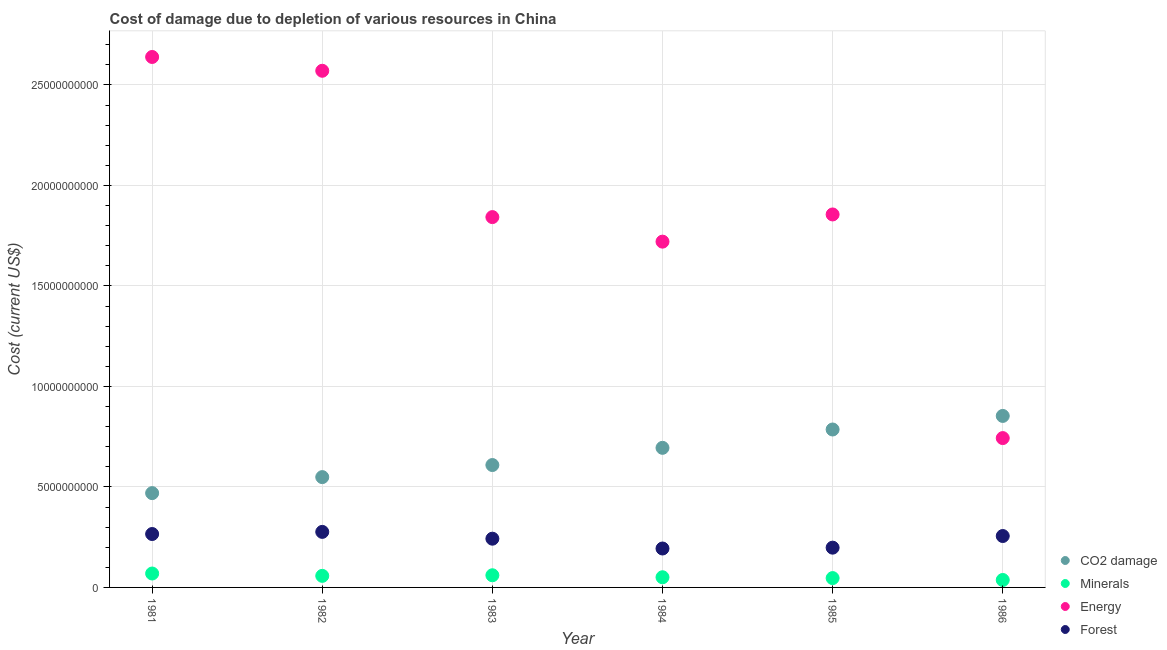How many different coloured dotlines are there?
Provide a succinct answer. 4. Is the number of dotlines equal to the number of legend labels?
Your response must be concise. Yes. What is the cost of damage due to depletion of minerals in 1981?
Make the answer very short. 6.92e+08. Across all years, what is the maximum cost of damage due to depletion of coal?
Your answer should be very brief. 8.53e+09. Across all years, what is the minimum cost of damage due to depletion of energy?
Your answer should be very brief. 7.43e+09. In which year was the cost of damage due to depletion of coal maximum?
Give a very brief answer. 1986. In which year was the cost of damage due to depletion of forests minimum?
Offer a terse response. 1984. What is the total cost of damage due to depletion of forests in the graph?
Your answer should be compact. 1.43e+1. What is the difference between the cost of damage due to depletion of minerals in 1982 and that in 1984?
Keep it short and to the point. 6.97e+07. What is the difference between the cost of damage due to depletion of minerals in 1983 and the cost of damage due to depletion of coal in 1986?
Offer a very short reply. -7.93e+09. What is the average cost of damage due to depletion of minerals per year?
Offer a terse response. 5.36e+08. In the year 1984, what is the difference between the cost of damage due to depletion of coal and cost of damage due to depletion of energy?
Provide a short and direct response. -1.03e+1. In how many years, is the cost of damage due to depletion of coal greater than 25000000000 US$?
Keep it short and to the point. 0. What is the ratio of the cost of damage due to depletion of minerals in 1984 to that in 1986?
Offer a terse response. 1.36. Is the difference between the cost of damage due to depletion of coal in 1981 and 1982 greater than the difference between the cost of damage due to depletion of minerals in 1981 and 1982?
Make the answer very short. No. What is the difference between the highest and the second highest cost of damage due to depletion of energy?
Offer a terse response. 6.87e+08. What is the difference between the highest and the lowest cost of damage due to depletion of minerals?
Keep it short and to the point. 3.21e+08. Is it the case that in every year, the sum of the cost of damage due to depletion of coal and cost of damage due to depletion of minerals is greater than the cost of damage due to depletion of energy?
Provide a short and direct response. No. Is the cost of damage due to depletion of energy strictly greater than the cost of damage due to depletion of minerals over the years?
Provide a short and direct response. Yes. How many years are there in the graph?
Offer a very short reply. 6. Does the graph contain any zero values?
Provide a succinct answer. No. Does the graph contain grids?
Provide a succinct answer. Yes. How many legend labels are there?
Give a very brief answer. 4. How are the legend labels stacked?
Make the answer very short. Vertical. What is the title of the graph?
Give a very brief answer. Cost of damage due to depletion of various resources in China . What is the label or title of the Y-axis?
Give a very brief answer. Cost (current US$). What is the Cost (current US$) in CO2 damage in 1981?
Your answer should be very brief. 4.69e+09. What is the Cost (current US$) in Minerals in 1981?
Your response must be concise. 6.92e+08. What is the Cost (current US$) in Energy in 1981?
Make the answer very short. 2.64e+1. What is the Cost (current US$) in Forest in 1981?
Give a very brief answer. 2.66e+09. What is the Cost (current US$) of CO2 damage in 1982?
Provide a succinct answer. 5.49e+09. What is the Cost (current US$) of Minerals in 1982?
Keep it short and to the point. 5.75e+08. What is the Cost (current US$) of Energy in 1982?
Offer a very short reply. 2.57e+1. What is the Cost (current US$) of Forest in 1982?
Your answer should be compact. 2.76e+09. What is the Cost (current US$) in CO2 damage in 1983?
Your response must be concise. 6.09e+09. What is the Cost (current US$) of Minerals in 1983?
Your response must be concise. 6.05e+08. What is the Cost (current US$) of Energy in 1983?
Make the answer very short. 1.84e+1. What is the Cost (current US$) of Forest in 1983?
Offer a terse response. 2.42e+09. What is the Cost (current US$) in CO2 damage in 1984?
Offer a terse response. 6.95e+09. What is the Cost (current US$) of Minerals in 1984?
Offer a terse response. 5.06e+08. What is the Cost (current US$) of Energy in 1984?
Make the answer very short. 1.72e+1. What is the Cost (current US$) in Forest in 1984?
Your answer should be compact. 1.94e+09. What is the Cost (current US$) in CO2 damage in 1985?
Make the answer very short. 7.86e+09. What is the Cost (current US$) in Minerals in 1985?
Ensure brevity in your answer.  4.65e+08. What is the Cost (current US$) in Energy in 1985?
Give a very brief answer. 1.86e+1. What is the Cost (current US$) in Forest in 1985?
Your answer should be compact. 1.98e+09. What is the Cost (current US$) in CO2 damage in 1986?
Provide a succinct answer. 8.53e+09. What is the Cost (current US$) in Minerals in 1986?
Your answer should be very brief. 3.71e+08. What is the Cost (current US$) in Energy in 1986?
Your answer should be compact. 7.43e+09. What is the Cost (current US$) of Forest in 1986?
Offer a terse response. 2.56e+09. Across all years, what is the maximum Cost (current US$) of CO2 damage?
Ensure brevity in your answer.  8.53e+09. Across all years, what is the maximum Cost (current US$) in Minerals?
Ensure brevity in your answer.  6.92e+08. Across all years, what is the maximum Cost (current US$) of Energy?
Your response must be concise. 2.64e+1. Across all years, what is the maximum Cost (current US$) of Forest?
Make the answer very short. 2.76e+09. Across all years, what is the minimum Cost (current US$) of CO2 damage?
Your answer should be compact. 4.69e+09. Across all years, what is the minimum Cost (current US$) in Minerals?
Offer a terse response. 3.71e+08. Across all years, what is the minimum Cost (current US$) in Energy?
Give a very brief answer. 7.43e+09. Across all years, what is the minimum Cost (current US$) in Forest?
Offer a very short reply. 1.94e+09. What is the total Cost (current US$) of CO2 damage in the graph?
Keep it short and to the point. 3.96e+1. What is the total Cost (current US$) in Minerals in the graph?
Provide a short and direct response. 3.21e+09. What is the total Cost (current US$) in Energy in the graph?
Give a very brief answer. 1.14e+11. What is the total Cost (current US$) in Forest in the graph?
Ensure brevity in your answer.  1.43e+1. What is the difference between the Cost (current US$) in CO2 damage in 1981 and that in 1982?
Ensure brevity in your answer.  -7.97e+08. What is the difference between the Cost (current US$) of Minerals in 1981 and that in 1982?
Keep it short and to the point. 1.17e+08. What is the difference between the Cost (current US$) in Energy in 1981 and that in 1982?
Your response must be concise. 6.87e+08. What is the difference between the Cost (current US$) of Forest in 1981 and that in 1982?
Keep it short and to the point. -1.06e+08. What is the difference between the Cost (current US$) in CO2 damage in 1981 and that in 1983?
Ensure brevity in your answer.  -1.40e+09. What is the difference between the Cost (current US$) of Minerals in 1981 and that in 1983?
Ensure brevity in your answer.  8.68e+07. What is the difference between the Cost (current US$) in Energy in 1981 and that in 1983?
Provide a succinct answer. 7.97e+09. What is the difference between the Cost (current US$) of Forest in 1981 and that in 1983?
Your response must be concise. 2.32e+08. What is the difference between the Cost (current US$) in CO2 damage in 1981 and that in 1984?
Give a very brief answer. -2.25e+09. What is the difference between the Cost (current US$) of Minerals in 1981 and that in 1984?
Your answer should be very brief. 1.86e+08. What is the difference between the Cost (current US$) of Energy in 1981 and that in 1984?
Provide a short and direct response. 9.19e+09. What is the difference between the Cost (current US$) in Forest in 1981 and that in 1984?
Provide a succinct answer. 7.21e+08. What is the difference between the Cost (current US$) in CO2 damage in 1981 and that in 1985?
Keep it short and to the point. -3.17e+09. What is the difference between the Cost (current US$) of Minerals in 1981 and that in 1985?
Provide a succinct answer. 2.27e+08. What is the difference between the Cost (current US$) of Energy in 1981 and that in 1985?
Provide a succinct answer. 7.84e+09. What is the difference between the Cost (current US$) in Forest in 1981 and that in 1985?
Give a very brief answer. 6.79e+08. What is the difference between the Cost (current US$) of CO2 damage in 1981 and that in 1986?
Offer a very short reply. -3.84e+09. What is the difference between the Cost (current US$) in Minerals in 1981 and that in 1986?
Your response must be concise. 3.21e+08. What is the difference between the Cost (current US$) in Energy in 1981 and that in 1986?
Provide a short and direct response. 1.90e+1. What is the difference between the Cost (current US$) of Forest in 1981 and that in 1986?
Your answer should be very brief. 9.98e+07. What is the difference between the Cost (current US$) in CO2 damage in 1982 and that in 1983?
Your answer should be very brief. -6.01e+08. What is the difference between the Cost (current US$) in Minerals in 1982 and that in 1983?
Your response must be concise. -2.98e+07. What is the difference between the Cost (current US$) of Energy in 1982 and that in 1983?
Keep it short and to the point. 7.28e+09. What is the difference between the Cost (current US$) in Forest in 1982 and that in 1983?
Give a very brief answer. 3.38e+08. What is the difference between the Cost (current US$) of CO2 damage in 1982 and that in 1984?
Offer a very short reply. -1.46e+09. What is the difference between the Cost (current US$) in Minerals in 1982 and that in 1984?
Make the answer very short. 6.97e+07. What is the difference between the Cost (current US$) in Energy in 1982 and that in 1984?
Give a very brief answer. 8.50e+09. What is the difference between the Cost (current US$) of Forest in 1982 and that in 1984?
Your answer should be compact. 8.27e+08. What is the difference between the Cost (current US$) of CO2 damage in 1982 and that in 1985?
Offer a terse response. -2.37e+09. What is the difference between the Cost (current US$) in Minerals in 1982 and that in 1985?
Your response must be concise. 1.11e+08. What is the difference between the Cost (current US$) in Energy in 1982 and that in 1985?
Provide a succinct answer. 7.15e+09. What is the difference between the Cost (current US$) of Forest in 1982 and that in 1985?
Offer a terse response. 7.85e+08. What is the difference between the Cost (current US$) in CO2 damage in 1982 and that in 1986?
Ensure brevity in your answer.  -3.04e+09. What is the difference between the Cost (current US$) in Minerals in 1982 and that in 1986?
Make the answer very short. 2.05e+08. What is the difference between the Cost (current US$) of Energy in 1982 and that in 1986?
Offer a terse response. 1.83e+1. What is the difference between the Cost (current US$) in Forest in 1982 and that in 1986?
Your response must be concise. 2.06e+08. What is the difference between the Cost (current US$) in CO2 damage in 1983 and that in 1984?
Offer a very short reply. -8.56e+08. What is the difference between the Cost (current US$) of Minerals in 1983 and that in 1984?
Offer a terse response. 9.95e+07. What is the difference between the Cost (current US$) in Energy in 1983 and that in 1984?
Offer a very short reply. 1.22e+09. What is the difference between the Cost (current US$) in Forest in 1983 and that in 1984?
Ensure brevity in your answer.  4.88e+08. What is the difference between the Cost (current US$) of CO2 damage in 1983 and that in 1985?
Make the answer very short. -1.77e+09. What is the difference between the Cost (current US$) of Minerals in 1983 and that in 1985?
Your answer should be very brief. 1.40e+08. What is the difference between the Cost (current US$) of Energy in 1983 and that in 1985?
Provide a short and direct response. -1.31e+08. What is the difference between the Cost (current US$) in Forest in 1983 and that in 1985?
Keep it short and to the point. 4.46e+08. What is the difference between the Cost (current US$) of CO2 damage in 1983 and that in 1986?
Your answer should be compact. -2.44e+09. What is the difference between the Cost (current US$) in Minerals in 1983 and that in 1986?
Offer a terse response. 2.34e+08. What is the difference between the Cost (current US$) of Energy in 1983 and that in 1986?
Your answer should be compact. 1.10e+1. What is the difference between the Cost (current US$) in Forest in 1983 and that in 1986?
Keep it short and to the point. -1.33e+08. What is the difference between the Cost (current US$) in CO2 damage in 1984 and that in 1985?
Provide a short and direct response. -9.12e+08. What is the difference between the Cost (current US$) of Minerals in 1984 and that in 1985?
Your answer should be compact. 4.10e+07. What is the difference between the Cost (current US$) in Energy in 1984 and that in 1985?
Keep it short and to the point. -1.35e+09. What is the difference between the Cost (current US$) in Forest in 1984 and that in 1985?
Make the answer very short. -4.19e+07. What is the difference between the Cost (current US$) of CO2 damage in 1984 and that in 1986?
Provide a short and direct response. -1.59e+09. What is the difference between the Cost (current US$) in Minerals in 1984 and that in 1986?
Your answer should be very brief. 1.35e+08. What is the difference between the Cost (current US$) of Energy in 1984 and that in 1986?
Give a very brief answer. 9.77e+09. What is the difference between the Cost (current US$) in Forest in 1984 and that in 1986?
Offer a very short reply. -6.21e+08. What is the difference between the Cost (current US$) of CO2 damage in 1985 and that in 1986?
Give a very brief answer. -6.75e+08. What is the difference between the Cost (current US$) in Minerals in 1985 and that in 1986?
Give a very brief answer. 9.40e+07. What is the difference between the Cost (current US$) in Energy in 1985 and that in 1986?
Provide a short and direct response. 1.11e+1. What is the difference between the Cost (current US$) of Forest in 1985 and that in 1986?
Keep it short and to the point. -5.79e+08. What is the difference between the Cost (current US$) in CO2 damage in 1981 and the Cost (current US$) in Minerals in 1982?
Give a very brief answer. 4.12e+09. What is the difference between the Cost (current US$) in CO2 damage in 1981 and the Cost (current US$) in Energy in 1982?
Make the answer very short. -2.10e+1. What is the difference between the Cost (current US$) in CO2 damage in 1981 and the Cost (current US$) in Forest in 1982?
Keep it short and to the point. 1.93e+09. What is the difference between the Cost (current US$) of Minerals in 1981 and the Cost (current US$) of Energy in 1982?
Provide a succinct answer. -2.50e+1. What is the difference between the Cost (current US$) of Minerals in 1981 and the Cost (current US$) of Forest in 1982?
Your response must be concise. -2.07e+09. What is the difference between the Cost (current US$) of Energy in 1981 and the Cost (current US$) of Forest in 1982?
Offer a terse response. 2.36e+1. What is the difference between the Cost (current US$) of CO2 damage in 1981 and the Cost (current US$) of Minerals in 1983?
Your answer should be very brief. 4.09e+09. What is the difference between the Cost (current US$) of CO2 damage in 1981 and the Cost (current US$) of Energy in 1983?
Your answer should be compact. -1.37e+1. What is the difference between the Cost (current US$) of CO2 damage in 1981 and the Cost (current US$) of Forest in 1983?
Offer a very short reply. 2.27e+09. What is the difference between the Cost (current US$) of Minerals in 1981 and the Cost (current US$) of Energy in 1983?
Offer a terse response. -1.77e+1. What is the difference between the Cost (current US$) of Minerals in 1981 and the Cost (current US$) of Forest in 1983?
Your answer should be compact. -1.73e+09. What is the difference between the Cost (current US$) of Energy in 1981 and the Cost (current US$) of Forest in 1983?
Give a very brief answer. 2.40e+1. What is the difference between the Cost (current US$) in CO2 damage in 1981 and the Cost (current US$) in Minerals in 1984?
Provide a succinct answer. 4.19e+09. What is the difference between the Cost (current US$) in CO2 damage in 1981 and the Cost (current US$) in Energy in 1984?
Offer a very short reply. -1.25e+1. What is the difference between the Cost (current US$) of CO2 damage in 1981 and the Cost (current US$) of Forest in 1984?
Provide a short and direct response. 2.76e+09. What is the difference between the Cost (current US$) of Minerals in 1981 and the Cost (current US$) of Energy in 1984?
Provide a short and direct response. -1.65e+1. What is the difference between the Cost (current US$) of Minerals in 1981 and the Cost (current US$) of Forest in 1984?
Offer a very short reply. -1.24e+09. What is the difference between the Cost (current US$) of Energy in 1981 and the Cost (current US$) of Forest in 1984?
Keep it short and to the point. 2.45e+1. What is the difference between the Cost (current US$) in CO2 damage in 1981 and the Cost (current US$) in Minerals in 1985?
Your answer should be compact. 4.23e+09. What is the difference between the Cost (current US$) in CO2 damage in 1981 and the Cost (current US$) in Energy in 1985?
Your answer should be very brief. -1.39e+1. What is the difference between the Cost (current US$) in CO2 damage in 1981 and the Cost (current US$) in Forest in 1985?
Your answer should be very brief. 2.71e+09. What is the difference between the Cost (current US$) in Minerals in 1981 and the Cost (current US$) in Energy in 1985?
Ensure brevity in your answer.  -1.79e+1. What is the difference between the Cost (current US$) of Minerals in 1981 and the Cost (current US$) of Forest in 1985?
Your answer should be compact. -1.29e+09. What is the difference between the Cost (current US$) in Energy in 1981 and the Cost (current US$) in Forest in 1985?
Your response must be concise. 2.44e+1. What is the difference between the Cost (current US$) of CO2 damage in 1981 and the Cost (current US$) of Minerals in 1986?
Your answer should be compact. 4.32e+09. What is the difference between the Cost (current US$) of CO2 damage in 1981 and the Cost (current US$) of Energy in 1986?
Offer a terse response. -2.74e+09. What is the difference between the Cost (current US$) in CO2 damage in 1981 and the Cost (current US$) in Forest in 1986?
Offer a very short reply. 2.13e+09. What is the difference between the Cost (current US$) of Minerals in 1981 and the Cost (current US$) of Energy in 1986?
Your answer should be compact. -6.74e+09. What is the difference between the Cost (current US$) of Minerals in 1981 and the Cost (current US$) of Forest in 1986?
Provide a succinct answer. -1.87e+09. What is the difference between the Cost (current US$) in Energy in 1981 and the Cost (current US$) in Forest in 1986?
Ensure brevity in your answer.  2.38e+1. What is the difference between the Cost (current US$) of CO2 damage in 1982 and the Cost (current US$) of Minerals in 1983?
Your response must be concise. 4.88e+09. What is the difference between the Cost (current US$) in CO2 damage in 1982 and the Cost (current US$) in Energy in 1983?
Give a very brief answer. -1.29e+1. What is the difference between the Cost (current US$) in CO2 damage in 1982 and the Cost (current US$) in Forest in 1983?
Ensure brevity in your answer.  3.06e+09. What is the difference between the Cost (current US$) in Minerals in 1982 and the Cost (current US$) in Energy in 1983?
Keep it short and to the point. -1.78e+1. What is the difference between the Cost (current US$) in Minerals in 1982 and the Cost (current US$) in Forest in 1983?
Offer a very short reply. -1.85e+09. What is the difference between the Cost (current US$) of Energy in 1982 and the Cost (current US$) of Forest in 1983?
Keep it short and to the point. 2.33e+1. What is the difference between the Cost (current US$) of CO2 damage in 1982 and the Cost (current US$) of Minerals in 1984?
Keep it short and to the point. 4.98e+09. What is the difference between the Cost (current US$) of CO2 damage in 1982 and the Cost (current US$) of Energy in 1984?
Ensure brevity in your answer.  -1.17e+1. What is the difference between the Cost (current US$) of CO2 damage in 1982 and the Cost (current US$) of Forest in 1984?
Your answer should be very brief. 3.55e+09. What is the difference between the Cost (current US$) of Minerals in 1982 and the Cost (current US$) of Energy in 1984?
Provide a succinct answer. -1.66e+1. What is the difference between the Cost (current US$) of Minerals in 1982 and the Cost (current US$) of Forest in 1984?
Make the answer very short. -1.36e+09. What is the difference between the Cost (current US$) in Energy in 1982 and the Cost (current US$) in Forest in 1984?
Offer a very short reply. 2.38e+1. What is the difference between the Cost (current US$) in CO2 damage in 1982 and the Cost (current US$) in Minerals in 1985?
Your answer should be very brief. 5.02e+09. What is the difference between the Cost (current US$) in CO2 damage in 1982 and the Cost (current US$) in Energy in 1985?
Offer a terse response. -1.31e+1. What is the difference between the Cost (current US$) of CO2 damage in 1982 and the Cost (current US$) of Forest in 1985?
Ensure brevity in your answer.  3.51e+09. What is the difference between the Cost (current US$) of Minerals in 1982 and the Cost (current US$) of Energy in 1985?
Offer a very short reply. -1.80e+1. What is the difference between the Cost (current US$) in Minerals in 1982 and the Cost (current US$) in Forest in 1985?
Your answer should be very brief. -1.40e+09. What is the difference between the Cost (current US$) of Energy in 1982 and the Cost (current US$) of Forest in 1985?
Give a very brief answer. 2.37e+1. What is the difference between the Cost (current US$) of CO2 damage in 1982 and the Cost (current US$) of Minerals in 1986?
Ensure brevity in your answer.  5.12e+09. What is the difference between the Cost (current US$) of CO2 damage in 1982 and the Cost (current US$) of Energy in 1986?
Your answer should be very brief. -1.94e+09. What is the difference between the Cost (current US$) in CO2 damage in 1982 and the Cost (current US$) in Forest in 1986?
Your answer should be compact. 2.93e+09. What is the difference between the Cost (current US$) in Minerals in 1982 and the Cost (current US$) in Energy in 1986?
Your answer should be compact. -6.85e+09. What is the difference between the Cost (current US$) in Minerals in 1982 and the Cost (current US$) in Forest in 1986?
Ensure brevity in your answer.  -1.98e+09. What is the difference between the Cost (current US$) in Energy in 1982 and the Cost (current US$) in Forest in 1986?
Keep it short and to the point. 2.31e+1. What is the difference between the Cost (current US$) of CO2 damage in 1983 and the Cost (current US$) of Minerals in 1984?
Offer a terse response. 5.58e+09. What is the difference between the Cost (current US$) in CO2 damage in 1983 and the Cost (current US$) in Energy in 1984?
Your response must be concise. -1.11e+1. What is the difference between the Cost (current US$) in CO2 damage in 1983 and the Cost (current US$) in Forest in 1984?
Your response must be concise. 4.15e+09. What is the difference between the Cost (current US$) in Minerals in 1983 and the Cost (current US$) in Energy in 1984?
Your response must be concise. -1.66e+1. What is the difference between the Cost (current US$) in Minerals in 1983 and the Cost (current US$) in Forest in 1984?
Provide a short and direct response. -1.33e+09. What is the difference between the Cost (current US$) in Energy in 1983 and the Cost (current US$) in Forest in 1984?
Make the answer very short. 1.65e+1. What is the difference between the Cost (current US$) in CO2 damage in 1983 and the Cost (current US$) in Minerals in 1985?
Offer a terse response. 5.62e+09. What is the difference between the Cost (current US$) in CO2 damage in 1983 and the Cost (current US$) in Energy in 1985?
Ensure brevity in your answer.  -1.25e+1. What is the difference between the Cost (current US$) in CO2 damage in 1983 and the Cost (current US$) in Forest in 1985?
Provide a short and direct response. 4.11e+09. What is the difference between the Cost (current US$) of Minerals in 1983 and the Cost (current US$) of Energy in 1985?
Your answer should be very brief. -1.80e+1. What is the difference between the Cost (current US$) in Minerals in 1983 and the Cost (current US$) in Forest in 1985?
Provide a succinct answer. -1.37e+09. What is the difference between the Cost (current US$) in Energy in 1983 and the Cost (current US$) in Forest in 1985?
Keep it short and to the point. 1.64e+1. What is the difference between the Cost (current US$) of CO2 damage in 1983 and the Cost (current US$) of Minerals in 1986?
Make the answer very short. 5.72e+09. What is the difference between the Cost (current US$) in CO2 damage in 1983 and the Cost (current US$) in Energy in 1986?
Provide a succinct answer. -1.34e+09. What is the difference between the Cost (current US$) of CO2 damage in 1983 and the Cost (current US$) of Forest in 1986?
Ensure brevity in your answer.  3.53e+09. What is the difference between the Cost (current US$) in Minerals in 1983 and the Cost (current US$) in Energy in 1986?
Provide a succinct answer. -6.82e+09. What is the difference between the Cost (current US$) in Minerals in 1983 and the Cost (current US$) in Forest in 1986?
Provide a short and direct response. -1.95e+09. What is the difference between the Cost (current US$) in Energy in 1983 and the Cost (current US$) in Forest in 1986?
Your answer should be compact. 1.59e+1. What is the difference between the Cost (current US$) of CO2 damage in 1984 and the Cost (current US$) of Minerals in 1985?
Your response must be concise. 6.48e+09. What is the difference between the Cost (current US$) of CO2 damage in 1984 and the Cost (current US$) of Energy in 1985?
Your response must be concise. -1.16e+1. What is the difference between the Cost (current US$) of CO2 damage in 1984 and the Cost (current US$) of Forest in 1985?
Your answer should be compact. 4.97e+09. What is the difference between the Cost (current US$) of Minerals in 1984 and the Cost (current US$) of Energy in 1985?
Give a very brief answer. -1.81e+1. What is the difference between the Cost (current US$) in Minerals in 1984 and the Cost (current US$) in Forest in 1985?
Your answer should be very brief. -1.47e+09. What is the difference between the Cost (current US$) of Energy in 1984 and the Cost (current US$) of Forest in 1985?
Provide a succinct answer. 1.52e+1. What is the difference between the Cost (current US$) of CO2 damage in 1984 and the Cost (current US$) of Minerals in 1986?
Offer a very short reply. 6.57e+09. What is the difference between the Cost (current US$) in CO2 damage in 1984 and the Cost (current US$) in Energy in 1986?
Make the answer very short. -4.85e+08. What is the difference between the Cost (current US$) of CO2 damage in 1984 and the Cost (current US$) of Forest in 1986?
Provide a short and direct response. 4.39e+09. What is the difference between the Cost (current US$) in Minerals in 1984 and the Cost (current US$) in Energy in 1986?
Give a very brief answer. -6.92e+09. What is the difference between the Cost (current US$) of Minerals in 1984 and the Cost (current US$) of Forest in 1986?
Make the answer very short. -2.05e+09. What is the difference between the Cost (current US$) of Energy in 1984 and the Cost (current US$) of Forest in 1986?
Give a very brief answer. 1.46e+1. What is the difference between the Cost (current US$) in CO2 damage in 1985 and the Cost (current US$) in Minerals in 1986?
Ensure brevity in your answer.  7.49e+09. What is the difference between the Cost (current US$) of CO2 damage in 1985 and the Cost (current US$) of Energy in 1986?
Keep it short and to the point. 4.27e+08. What is the difference between the Cost (current US$) in CO2 damage in 1985 and the Cost (current US$) in Forest in 1986?
Provide a short and direct response. 5.30e+09. What is the difference between the Cost (current US$) in Minerals in 1985 and the Cost (current US$) in Energy in 1986?
Provide a succinct answer. -6.97e+09. What is the difference between the Cost (current US$) in Minerals in 1985 and the Cost (current US$) in Forest in 1986?
Provide a succinct answer. -2.09e+09. What is the difference between the Cost (current US$) of Energy in 1985 and the Cost (current US$) of Forest in 1986?
Your response must be concise. 1.60e+1. What is the average Cost (current US$) in CO2 damage per year?
Ensure brevity in your answer.  6.60e+09. What is the average Cost (current US$) in Minerals per year?
Offer a terse response. 5.36e+08. What is the average Cost (current US$) in Energy per year?
Provide a succinct answer. 1.90e+1. What is the average Cost (current US$) in Forest per year?
Give a very brief answer. 2.39e+09. In the year 1981, what is the difference between the Cost (current US$) in CO2 damage and Cost (current US$) in Minerals?
Your answer should be compact. 4.00e+09. In the year 1981, what is the difference between the Cost (current US$) in CO2 damage and Cost (current US$) in Energy?
Offer a very short reply. -2.17e+1. In the year 1981, what is the difference between the Cost (current US$) of CO2 damage and Cost (current US$) of Forest?
Offer a terse response. 2.03e+09. In the year 1981, what is the difference between the Cost (current US$) of Minerals and Cost (current US$) of Energy?
Provide a short and direct response. -2.57e+1. In the year 1981, what is the difference between the Cost (current US$) in Minerals and Cost (current US$) in Forest?
Your answer should be compact. -1.97e+09. In the year 1981, what is the difference between the Cost (current US$) in Energy and Cost (current US$) in Forest?
Provide a succinct answer. 2.37e+1. In the year 1982, what is the difference between the Cost (current US$) of CO2 damage and Cost (current US$) of Minerals?
Provide a short and direct response. 4.91e+09. In the year 1982, what is the difference between the Cost (current US$) of CO2 damage and Cost (current US$) of Energy?
Keep it short and to the point. -2.02e+1. In the year 1982, what is the difference between the Cost (current US$) of CO2 damage and Cost (current US$) of Forest?
Ensure brevity in your answer.  2.73e+09. In the year 1982, what is the difference between the Cost (current US$) in Minerals and Cost (current US$) in Energy?
Your answer should be very brief. -2.51e+1. In the year 1982, what is the difference between the Cost (current US$) in Minerals and Cost (current US$) in Forest?
Provide a succinct answer. -2.19e+09. In the year 1982, what is the difference between the Cost (current US$) in Energy and Cost (current US$) in Forest?
Your answer should be very brief. 2.29e+1. In the year 1983, what is the difference between the Cost (current US$) in CO2 damage and Cost (current US$) in Minerals?
Offer a terse response. 5.48e+09. In the year 1983, what is the difference between the Cost (current US$) in CO2 damage and Cost (current US$) in Energy?
Your answer should be compact. -1.23e+1. In the year 1983, what is the difference between the Cost (current US$) of CO2 damage and Cost (current US$) of Forest?
Provide a succinct answer. 3.66e+09. In the year 1983, what is the difference between the Cost (current US$) in Minerals and Cost (current US$) in Energy?
Give a very brief answer. -1.78e+1. In the year 1983, what is the difference between the Cost (current US$) in Minerals and Cost (current US$) in Forest?
Offer a very short reply. -1.82e+09. In the year 1983, what is the difference between the Cost (current US$) in Energy and Cost (current US$) in Forest?
Your response must be concise. 1.60e+1. In the year 1984, what is the difference between the Cost (current US$) in CO2 damage and Cost (current US$) in Minerals?
Your answer should be compact. 6.44e+09. In the year 1984, what is the difference between the Cost (current US$) of CO2 damage and Cost (current US$) of Energy?
Provide a short and direct response. -1.03e+1. In the year 1984, what is the difference between the Cost (current US$) of CO2 damage and Cost (current US$) of Forest?
Your answer should be compact. 5.01e+09. In the year 1984, what is the difference between the Cost (current US$) in Minerals and Cost (current US$) in Energy?
Provide a succinct answer. -1.67e+1. In the year 1984, what is the difference between the Cost (current US$) in Minerals and Cost (current US$) in Forest?
Provide a succinct answer. -1.43e+09. In the year 1984, what is the difference between the Cost (current US$) in Energy and Cost (current US$) in Forest?
Provide a short and direct response. 1.53e+1. In the year 1985, what is the difference between the Cost (current US$) of CO2 damage and Cost (current US$) of Minerals?
Make the answer very short. 7.39e+09. In the year 1985, what is the difference between the Cost (current US$) of CO2 damage and Cost (current US$) of Energy?
Offer a very short reply. -1.07e+1. In the year 1985, what is the difference between the Cost (current US$) in CO2 damage and Cost (current US$) in Forest?
Your answer should be very brief. 5.88e+09. In the year 1985, what is the difference between the Cost (current US$) of Minerals and Cost (current US$) of Energy?
Keep it short and to the point. -1.81e+1. In the year 1985, what is the difference between the Cost (current US$) in Minerals and Cost (current US$) in Forest?
Make the answer very short. -1.51e+09. In the year 1985, what is the difference between the Cost (current US$) in Energy and Cost (current US$) in Forest?
Your answer should be very brief. 1.66e+1. In the year 1986, what is the difference between the Cost (current US$) of CO2 damage and Cost (current US$) of Minerals?
Make the answer very short. 8.16e+09. In the year 1986, what is the difference between the Cost (current US$) in CO2 damage and Cost (current US$) in Energy?
Give a very brief answer. 1.10e+09. In the year 1986, what is the difference between the Cost (current US$) of CO2 damage and Cost (current US$) of Forest?
Provide a short and direct response. 5.98e+09. In the year 1986, what is the difference between the Cost (current US$) of Minerals and Cost (current US$) of Energy?
Give a very brief answer. -7.06e+09. In the year 1986, what is the difference between the Cost (current US$) of Minerals and Cost (current US$) of Forest?
Your answer should be compact. -2.19e+09. In the year 1986, what is the difference between the Cost (current US$) in Energy and Cost (current US$) in Forest?
Give a very brief answer. 4.87e+09. What is the ratio of the Cost (current US$) of CO2 damage in 1981 to that in 1982?
Offer a terse response. 0.85. What is the ratio of the Cost (current US$) in Minerals in 1981 to that in 1982?
Provide a short and direct response. 1.2. What is the ratio of the Cost (current US$) in Energy in 1981 to that in 1982?
Give a very brief answer. 1.03. What is the ratio of the Cost (current US$) in Forest in 1981 to that in 1982?
Make the answer very short. 0.96. What is the ratio of the Cost (current US$) of CO2 damage in 1981 to that in 1983?
Your response must be concise. 0.77. What is the ratio of the Cost (current US$) in Minerals in 1981 to that in 1983?
Your response must be concise. 1.14. What is the ratio of the Cost (current US$) of Energy in 1981 to that in 1983?
Offer a very short reply. 1.43. What is the ratio of the Cost (current US$) of Forest in 1981 to that in 1983?
Give a very brief answer. 1.1. What is the ratio of the Cost (current US$) in CO2 damage in 1981 to that in 1984?
Ensure brevity in your answer.  0.68. What is the ratio of the Cost (current US$) of Minerals in 1981 to that in 1984?
Make the answer very short. 1.37. What is the ratio of the Cost (current US$) of Energy in 1981 to that in 1984?
Keep it short and to the point. 1.53. What is the ratio of the Cost (current US$) in Forest in 1981 to that in 1984?
Make the answer very short. 1.37. What is the ratio of the Cost (current US$) of CO2 damage in 1981 to that in 1985?
Provide a succinct answer. 0.6. What is the ratio of the Cost (current US$) of Minerals in 1981 to that in 1985?
Keep it short and to the point. 1.49. What is the ratio of the Cost (current US$) of Energy in 1981 to that in 1985?
Your answer should be compact. 1.42. What is the ratio of the Cost (current US$) in Forest in 1981 to that in 1985?
Provide a short and direct response. 1.34. What is the ratio of the Cost (current US$) of CO2 damage in 1981 to that in 1986?
Your answer should be compact. 0.55. What is the ratio of the Cost (current US$) of Minerals in 1981 to that in 1986?
Provide a succinct answer. 1.87. What is the ratio of the Cost (current US$) of Energy in 1981 to that in 1986?
Your answer should be compact. 3.55. What is the ratio of the Cost (current US$) in Forest in 1981 to that in 1986?
Your answer should be compact. 1.04. What is the ratio of the Cost (current US$) in CO2 damage in 1982 to that in 1983?
Provide a succinct answer. 0.9. What is the ratio of the Cost (current US$) in Minerals in 1982 to that in 1983?
Your response must be concise. 0.95. What is the ratio of the Cost (current US$) in Energy in 1982 to that in 1983?
Offer a very short reply. 1.4. What is the ratio of the Cost (current US$) in Forest in 1982 to that in 1983?
Provide a succinct answer. 1.14. What is the ratio of the Cost (current US$) in CO2 damage in 1982 to that in 1984?
Ensure brevity in your answer.  0.79. What is the ratio of the Cost (current US$) in Minerals in 1982 to that in 1984?
Offer a terse response. 1.14. What is the ratio of the Cost (current US$) in Energy in 1982 to that in 1984?
Your answer should be very brief. 1.49. What is the ratio of the Cost (current US$) of Forest in 1982 to that in 1984?
Your answer should be very brief. 1.43. What is the ratio of the Cost (current US$) in CO2 damage in 1982 to that in 1985?
Your answer should be very brief. 0.7. What is the ratio of the Cost (current US$) of Minerals in 1982 to that in 1985?
Give a very brief answer. 1.24. What is the ratio of the Cost (current US$) in Energy in 1982 to that in 1985?
Make the answer very short. 1.39. What is the ratio of the Cost (current US$) of Forest in 1982 to that in 1985?
Your answer should be very brief. 1.4. What is the ratio of the Cost (current US$) in CO2 damage in 1982 to that in 1986?
Keep it short and to the point. 0.64. What is the ratio of the Cost (current US$) of Minerals in 1982 to that in 1986?
Ensure brevity in your answer.  1.55. What is the ratio of the Cost (current US$) in Energy in 1982 to that in 1986?
Offer a very short reply. 3.46. What is the ratio of the Cost (current US$) of Forest in 1982 to that in 1986?
Ensure brevity in your answer.  1.08. What is the ratio of the Cost (current US$) in CO2 damage in 1983 to that in 1984?
Offer a terse response. 0.88. What is the ratio of the Cost (current US$) in Minerals in 1983 to that in 1984?
Give a very brief answer. 1.2. What is the ratio of the Cost (current US$) of Energy in 1983 to that in 1984?
Give a very brief answer. 1.07. What is the ratio of the Cost (current US$) in Forest in 1983 to that in 1984?
Provide a succinct answer. 1.25. What is the ratio of the Cost (current US$) in CO2 damage in 1983 to that in 1985?
Offer a terse response. 0.77. What is the ratio of the Cost (current US$) of Minerals in 1983 to that in 1985?
Your response must be concise. 1.3. What is the ratio of the Cost (current US$) of Energy in 1983 to that in 1985?
Give a very brief answer. 0.99. What is the ratio of the Cost (current US$) in Forest in 1983 to that in 1985?
Provide a succinct answer. 1.23. What is the ratio of the Cost (current US$) in CO2 damage in 1983 to that in 1986?
Provide a short and direct response. 0.71. What is the ratio of the Cost (current US$) in Minerals in 1983 to that in 1986?
Your response must be concise. 1.63. What is the ratio of the Cost (current US$) in Energy in 1983 to that in 1986?
Offer a terse response. 2.48. What is the ratio of the Cost (current US$) in Forest in 1983 to that in 1986?
Ensure brevity in your answer.  0.95. What is the ratio of the Cost (current US$) of CO2 damage in 1984 to that in 1985?
Keep it short and to the point. 0.88. What is the ratio of the Cost (current US$) of Minerals in 1984 to that in 1985?
Give a very brief answer. 1.09. What is the ratio of the Cost (current US$) in Energy in 1984 to that in 1985?
Provide a succinct answer. 0.93. What is the ratio of the Cost (current US$) in Forest in 1984 to that in 1985?
Keep it short and to the point. 0.98. What is the ratio of the Cost (current US$) in CO2 damage in 1984 to that in 1986?
Ensure brevity in your answer.  0.81. What is the ratio of the Cost (current US$) of Minerals in 1984 to that in 1986?
Make the answer very short. 1.36. What is the ratio of the Cost (current US$) in Energy in 1984 to that in 1986?
Offer a terse response. 2.32. What is the ratio of the Cost (current US$) of Forest in 1984 to that in 1986?
Your response must be concise. 0.76. What is the ratio of the Cost (current US$) in CO2 damage in 1985 to that in 1986?
Make the answer very short. 0.92. What is the ratio of the Cost (current US$) of Minerals in 1985 to that in 1986?
Make the answer very short. 1.25. What is the ratio of the Cost (current US$) in Energy in 1985 to that in 1986?
Provide a short and direct response. 2.5. What is the ratio of the Cost (current US$) in Forest in 1985 to that in 1986?
Make the answer very short. 0.77. What is the difference between the highest and the second highest Cost (current US$) in CO2 damage?
Keep it short and to the point. 6.75e+08. What is the difference between the highest and the second highest Cost (current US$) in Minerals?
Provide a short and direct response. 8.68e+07. What is the difference between the highest and the second highest Cost (current US$) of Energy?
Provide a succinct answer. 6.87e+08. What is the difference between the highest and the second highest Cost (current US$) in Forest?
Your response must be concise. 1.06e+08. What is the difference between the highest and the lowest Cost (current US$) of CO2 damage?
Ensure brevity in your answer.  3.84e+09. What is the difference between the highest and the lowest Cost (current US$) in Minerals?
Your answer should be compact. 3.21e+08. What is the difference between the highest and the lowest Cost (current US$) of Energy?
Offer a terse response. 1.90e+1. What is the difference between the highest and the lowest Cost (current US$) in Forest?
Ensure brevity in your answer.  8.27e+08. 